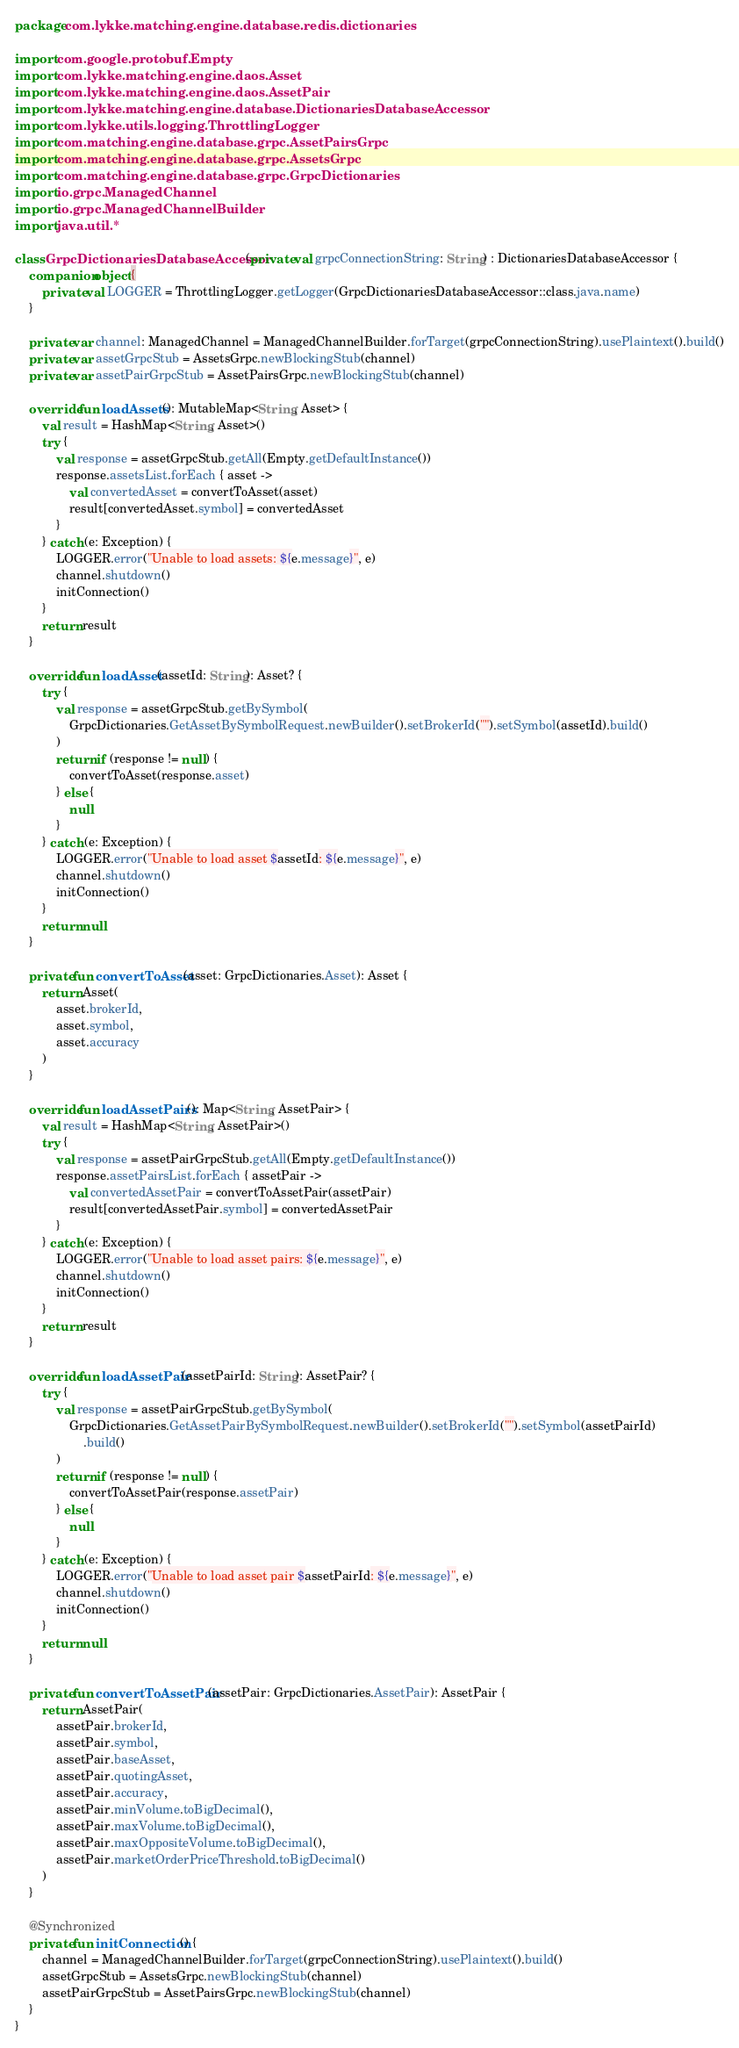Convert code to text. <code><loc_0><loc_0><loc_500><loc_500><_Kotlin_>package com.lykke.matching.engine.database.redis.dictionaries

import com.google.protobuf.Empty
import com.lykke.matching.engine.daos.Asset
import com.lykke.matching.engine.daos.AssetPair
import com.lykke.matching.engine.database.DictionariesDatabaseAccessor
import com.lykke.utils.logging.ThrottlingLogger
import com.matching.engine.database.grpc.AssetPairsGrpc
import com.matching.engine.database.grpc.AssetsGrpc
import com.matching.engine.database.grpc.GrpcDictionaries
import io.grpc.ManagedChannel
import io.grpc.ManagedChannelBuilder
import java.util.*

class GrpcDictionariesDatabaseAccessor(private val grpcConnectionString: String) : DictionariesDatabaseAccessor {
    companion object {
        private val LOGGER = ThrottlingLogger.getLogger(GrpcDictionariesDatabaseAccessor::class.java.name)
    }

    private var channel: ManagedChannel = ManagedChannelBuilder.forTarget(grpcConnectionString).usePlaintext().build()
    private var assetGrpcStub = AssetsGrpc.newBlockingStub(channel)
    private var assetPairGrpcStub = AssetPairsGrpc.newBlockingStub(channel)

    override fun loadAssets(): MutableMap<String, Asset> {
        val result = HashMap<String, Asset>()
        try {
            val response = assetGrpcStub.getAll(Empty.getDefaultInstance())
            response.assetsList.forEach { asset ->
                val convertedAsset = convertToAsset(asset)
                result[convertedAsset.symbol] = convertedAsset
            }
        } catch (e: Exception) {
            LOGGER.error("Unable to load assets: ${e.message}", e)
            channel.shutdown()
            initConnection()
        }
        return result
    }

    override fun loadAsset(assetId: String): Asset? {
        try {
            val response = assetGrpcStub.getBySymbol(
                GrpcDictionaries.GetAssetBySymbolRequest.newBuilder().setBrokerId("").setSymbol(assetId).build()
            )
            return if (response != null) {
                convertToAsset(response.asset)
            } else {
                null
            }
        } catch (e: Exception) {
            LOGGER.error("Unable to load asset $assetId: ${e.message}", e)
            channel.shutdown()
            initConnection()
        }
        return null
    }

    private fun convertToAsset(asset: GrpcDictionaries.Asset): Asset {
        return Asset(
            asset.brokerId,
            asset.symbol,
            asset.accuracy
        )
    }

    override fun loadAssetPairs(): Map<String, AssetPair> {
        val result = HashMap<String, AssetPair>()
        try {
            val response = assetPairGrpcStub.getAll(Empty.getDefaultInstance())
            response.assetPairsList.forEach { assetPair ->
                val convertedAssetPair = convertToAssetPair(assetPair)
                result[convertedAssetPair.symbol] = convertedAssetPair
            }
        } catch (e: Exception) {
            LOGGER.error("Unable to load asset pairs: ${e.message}", e)
            channel.shutdown()
            initConnection()
        }
        return result
    }

    override fun loadAssetPair(assetPairId: String): AssetPair? {
        try {
            val response = assetPairGrpcStub.getBySymbol(
                GrpcDictionaries.GetAssetPairBySymbolRequest.newBuilder().setBrokerId("").setSymbol(assetPairId)
                    .build()
            )
            return if (response != null) {
                convertToAssetPair(response.assetPair)
            } else {
                null
            }
        } catch (e: Exception) {
            LOGGER.error("Unable to load asset pair $assetPairId: ${e.message}", e)
            channel.shutdown()
            initConnection()
        }
        return null
    }

    private fun convertToAssetPair(assetPair: GrpcDictionaries.AssetPair): AssetPair {
        return AssetPair(
            assetPair.brokerId,
            assetPair.symbol,
            assetPair.baseAsset,
            assetPair.quotingAsset,
            assetPair.accuracy,
            assetPair.minVolume.toBigDecimal(),
            assetPair.maxVolume.toBigDecimal(),
            assetPair.maxOppositeVolume.toBigDecimal(),
            assetPair.marketOrderPriceThreshold.toBigDecimal()
        )
    }

    @Synchronized
    private fun initConnection() {
        channel = ManagedChannelBuilder.forTarget(grpcConnectionString).usePlaintext().build()
        assetGrpcStub = AssetsGrpc.newBlockingStub(channel)
        assetPairGrpcStub = AssetPairsGrpc.newBlockingStub(channel)
    }
}</code> 